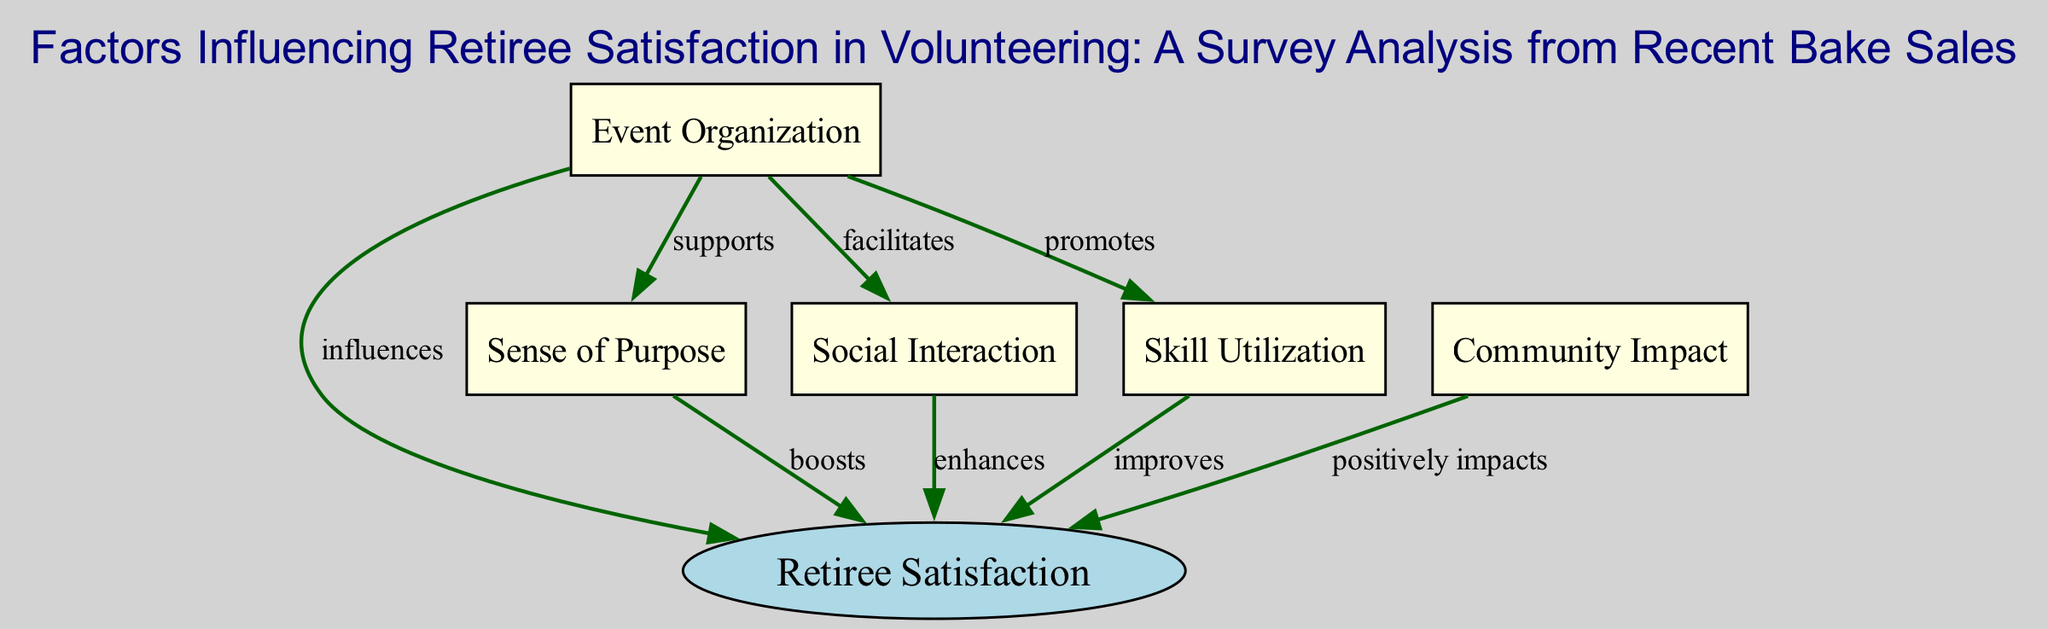What is the primary node representing the outcome of the factors? The primary node representing the outcome of the factors is indicated as "Retiree Satisfaction," which is at the top of the diagram and the focal point where all influences converge.
Answer: Retiree Satisfaction How many nodes are present in the diagram? By counting each unique node listed in the data, we find there are six nodes: one for "Retiree Satisfaction" and five others related to factors influencing it.
Answer: Six Which factor is said to "boost" retiree satisfaction? The edge labeled "boosts" originating from the "Sense of Purpose" node indicates that this factor increases retiree satisfaction.
Answer: Sense of Purpose What influence does "Event Organization" have on "Social Interaction"? The diagram shows that "Event Organization" facilitates "Social Interaction," which implies it helps create opportunities for social engagement among retirees.
Answer: Facilitates Which factor has a direct influence on both "Retiree Satisfaction" and "Skill Utilization"? The "Event Organization" factor directly influences "Retiree Satisfaction" as well as promotes "Skill Utilization," connecting it to both satisfaction and skill deployment.
Answer: Event Organization How many edges connect to the primary node "Retiree Satisfaction"? By examining the edges that point toward the "Retiree Satisfaction" node, we see there are five distinct edges indicating various influences on satisfaction.
Answer: Five Which factor positively impacts "Retiree Satisfaction"? The "Community Impact" factor is indicated to positively impact "Retiree Satisfaction," showing it contributes beneficially to the overall satisfaction experienced by retirees.
Answer: Community Impact Which two factors does "Event Organization" support and promote? "Event Organization" supports "Sense of Purpose" and promotes "Skill Utilization," as indicated by its connections to these nodes.
Answer: Sense of Purpose and Skill Utilization 